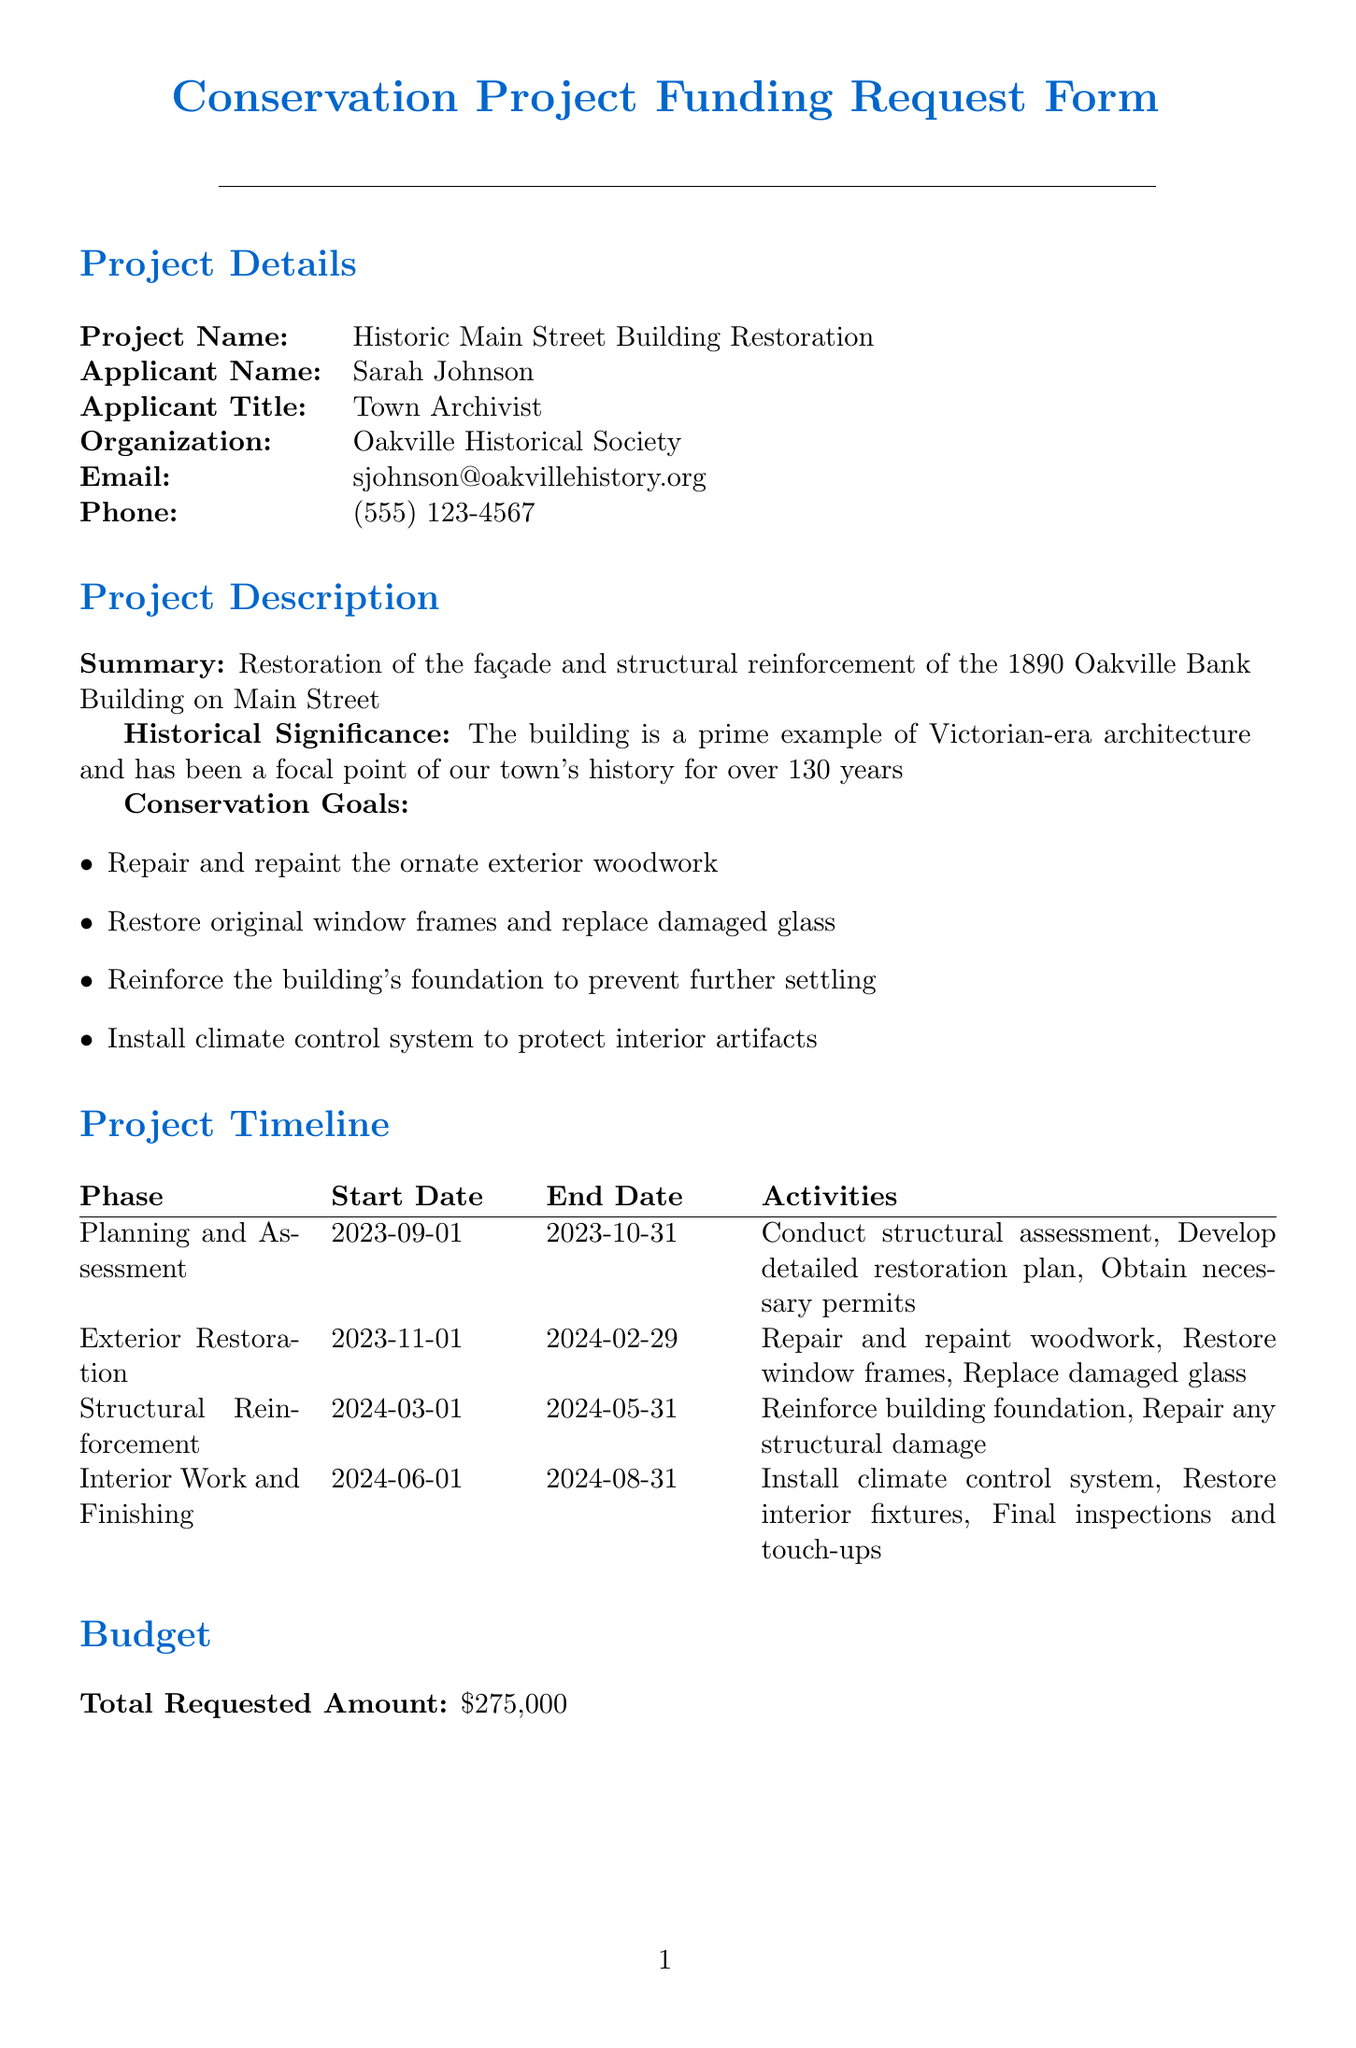What is the project name? The project name is stated in the project details section.
Answer: Historic Main Street Building Restoration Who is the applicant? The applicant's name is mentioned in the project details section.
Answer: Sarah Johnson What is the total requested amount? The total requested amount is summarized in the budget section of the document.
Answer: 275000 When does the Exterior Restoration phase start? The start date for the Exterior Restoration phase is listed in the project timeline.
Answer: 2023-11-01 What is the amount for Structural Reinforcement? The amount for Structural Reinforcement is specified in the itemized budget section.
Answer: 120000 How many conservation goals are listed? The number of conservation goals is determined by counting the items in the conservation goals list.
Answer: 4 What is the status of the State Historical Preservation Grant? The status is provided in the funding sources section of the document.
Answer: Pending approval Who supports the project as mayor? The mayor's name is noted in the Mayor's approval section.
Answer: Mayor Jennifer Thompson What document is required aside from architectural plans? The supporting documents section lists all necessary documents.
Answer: Historical significance report 